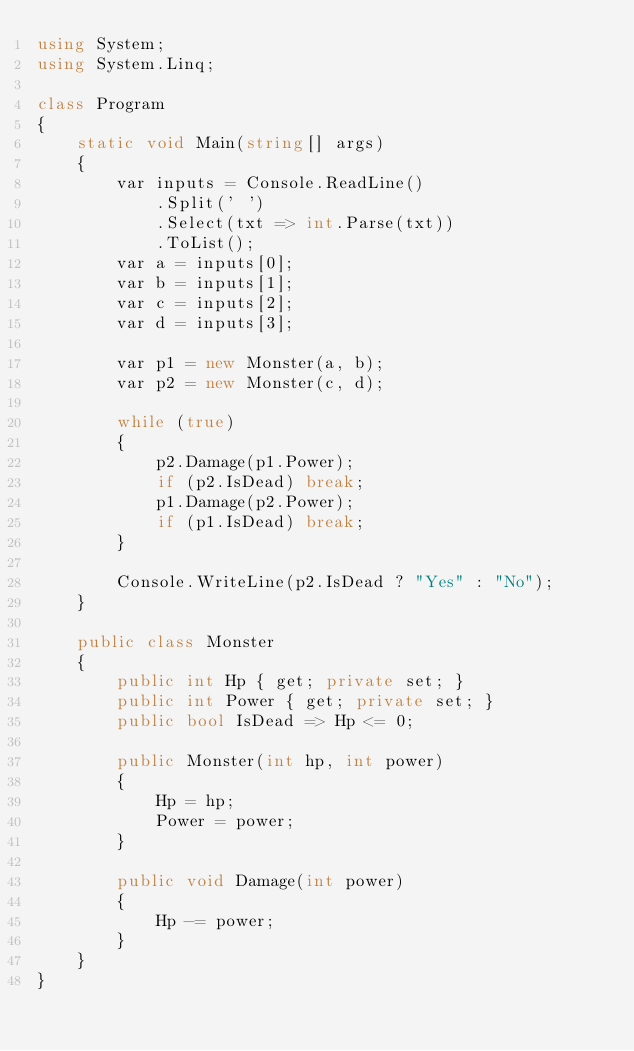Convert code to text. <code><loc_0><loc_0><loc_500><loc_500><_C#_>using System;
using System.Linq;

class Program
{
    static void Main(string[] args)
    {
        var inputs = Console.ReadLine()
            .Split(' ')
            .Select(txt => int.Parse(txt))
            .ToList();
        var a = inputs[0];
        var b = inputs[1];
        var c = inputs[2];
        var d = inputs[3];

        var p1 = new Monster(a, b);
        var p2 = new Monster(c, d);

        while (true)
        {
            p2.Damage(p1.Power);
            if (p2.IsDead) break;
            p1.Damage(p2.Power);
            if (p1.IsDead) break;
        }

        Console.WriteLine(p2.IsDead ? "Yes" : "No");
    }

    public class Monster
    {
        public int Hp { get; private set; }
        public int Power { get; private set; }
        public bool IsDead => Hp <= 0;

        public Monster(int hp, int power)
        {
            Hp = hp;
            Power = power;
        }

        public void Damage(int power)
        {
            Hp -= power;
        }
    }
}</code> 